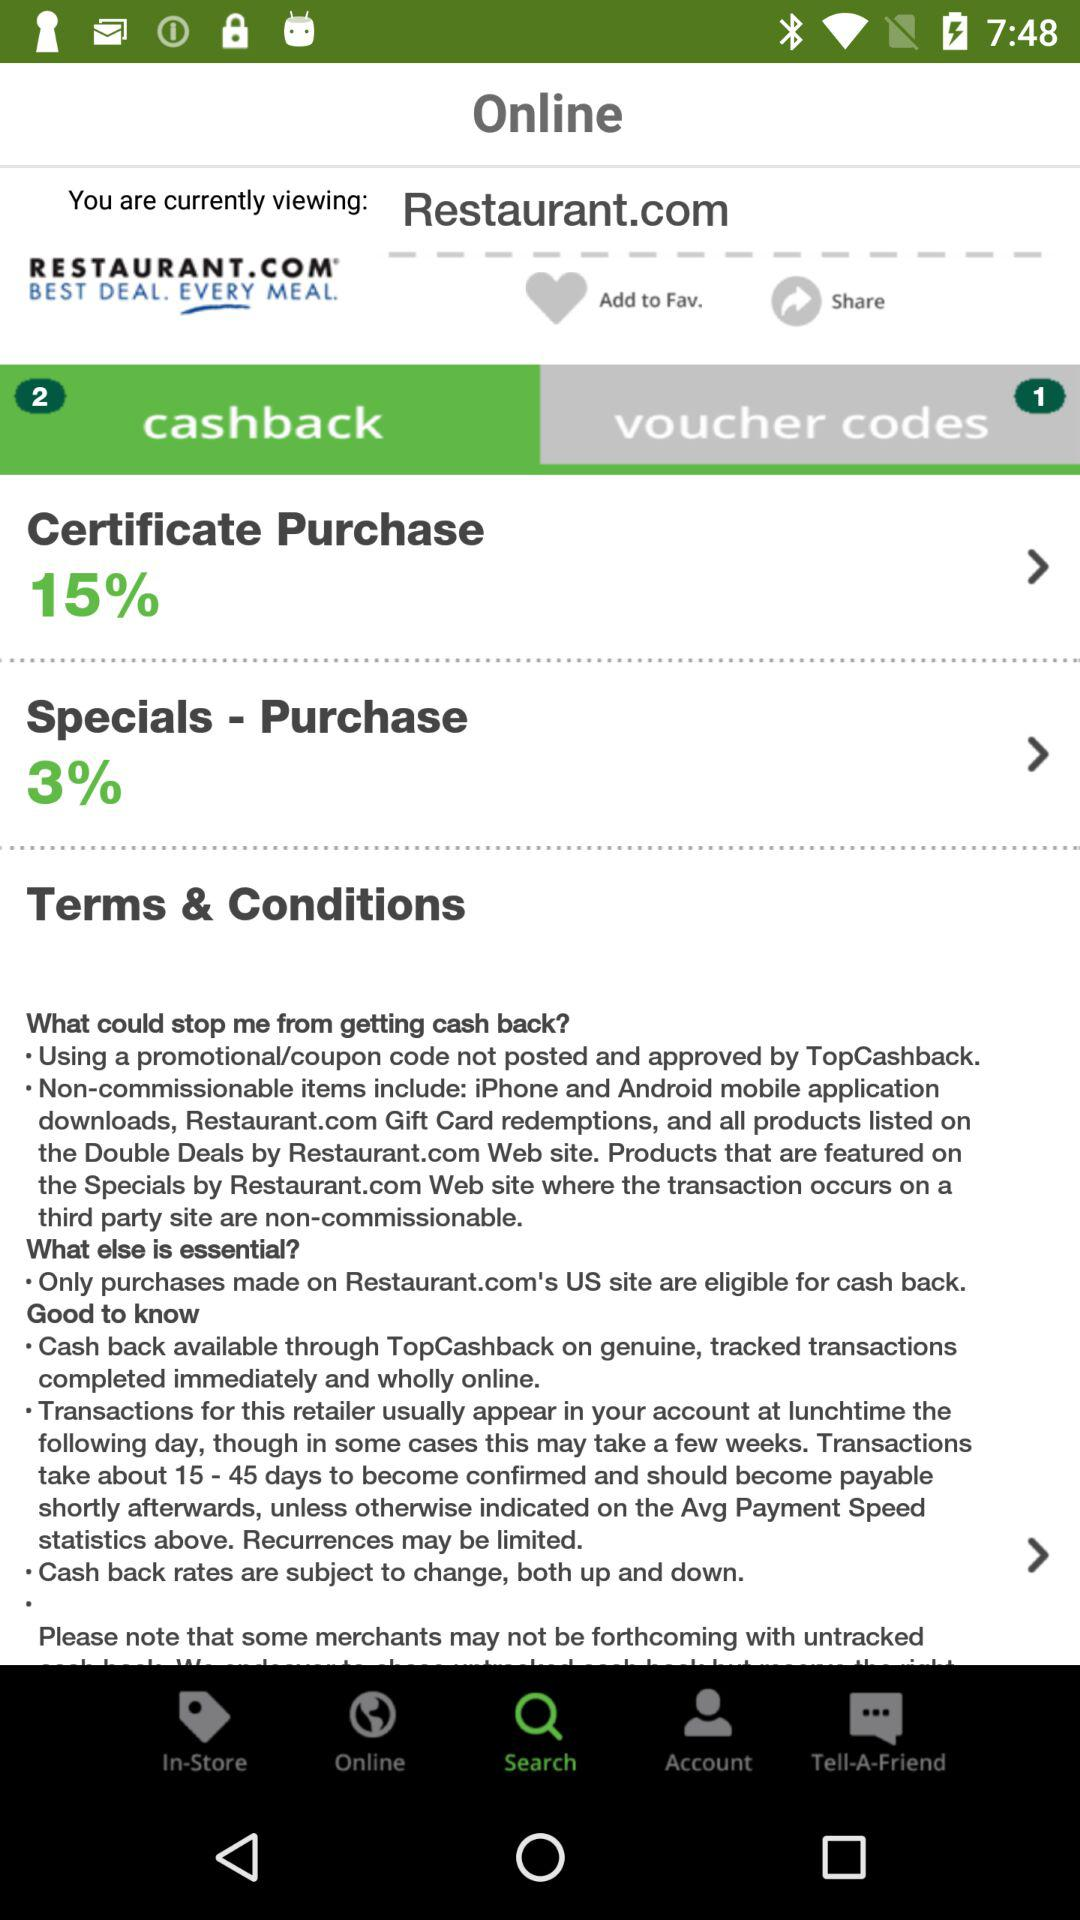How many cash back rates are displayed on this screen?
Answer the question using a single word or phrase. 2 